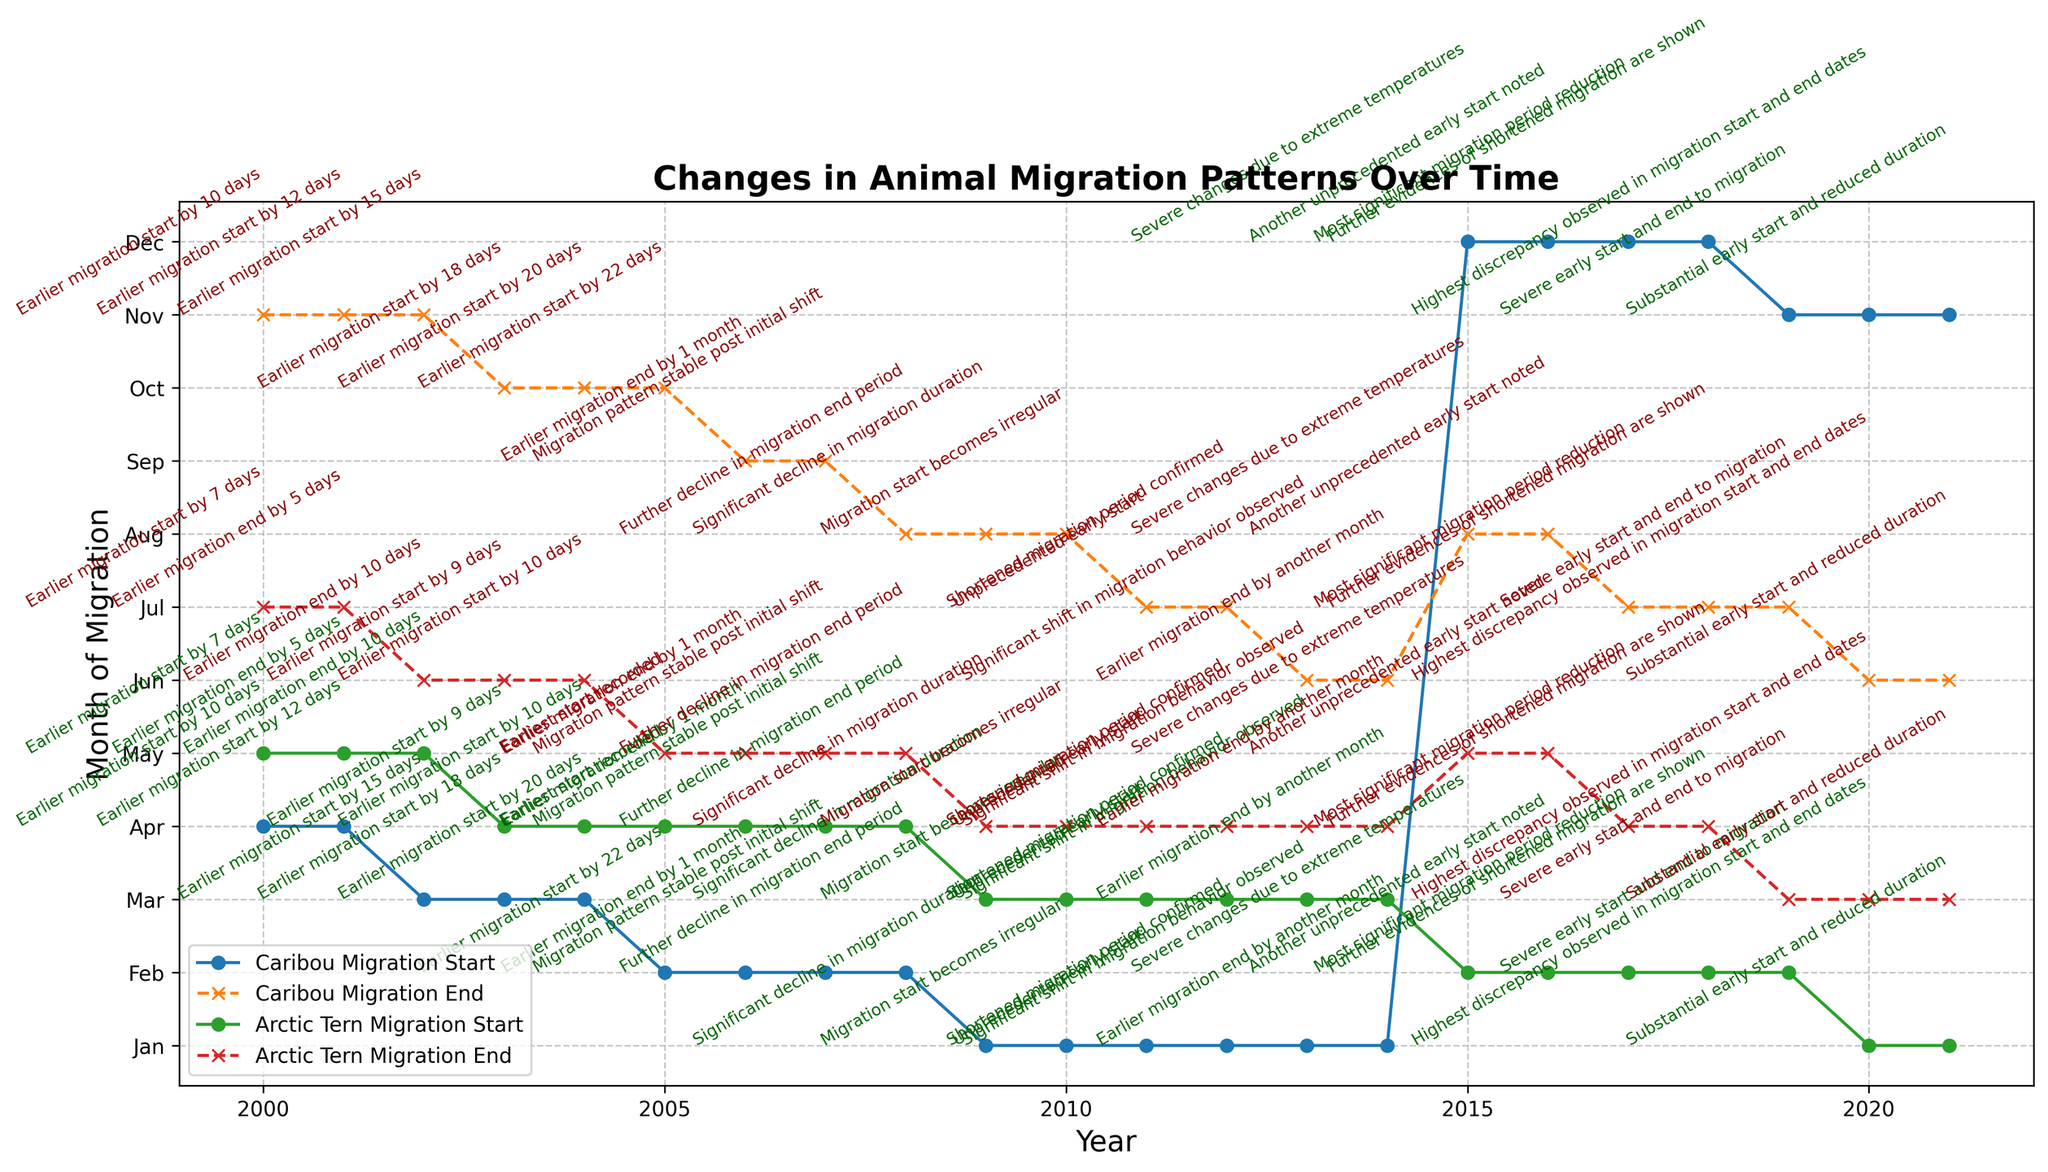Which animal had the earliest migration start in 2021? The figure indicates both the migration start and end months for each year. For 2021, check the migration start month for both Caribou and Arctic Tern. The Caribou's migration started in November, while the Arctic Tern's started in January.
Answer: Arctic Tern What was the migration end month for Caribou in 2006? Look at the end point of the line labeled "Caribou Migration End" in 2006. The figure's y-axis has month labels. In 2006, the line ends at September.
Answer: September How many years showed a significant shift in migration behavior for both animals? The text annotations indicate years with "significant shift in migration behavior observed." Look at the annotations on the figure for both Caribou and Arctic Tern. The year 2013 is noted with this significant shift for both animals.
Answer: 1 year (2013) Which animal had a migration pattern labeled "stable post initial shift" in 2007? Check the text annotations in the plot for 2007. Both Caribou and Arctic Tern lines have this label in 2007.
Answer: Both In which year did the Caribou’s migration start move to December? Follow the line labeled "Caribou Migration Start" and observe the text annotations along it until you find the shift to December. This change happens in 2015.
Answer: 2015 Which months show the greatest discrepancy in migration start and end dates for any animal? Look at the text annotations highlighting "Highest discrepancy observed in migration start and end dates." According to the annotations, this happens in 2020.
Answer: 2020 What is the latest migration end month recorded for Arctic Terns? Check the end points of the lines labeled "Arctic Tern Migration End" over all years. The latest end month is July, noted before 2006.
Answer: July How many days earlier did the Caribou start migrating in 2002? Refer to the text annotation next to the 2002 migration start point for Caribou. It mentions "Earlier migration start by 15 days."
Answer: 15 days Which months did both Caribou and Arctic Tern start migrating for the first time in 2010? Look at the migration start points for both animals in 2010 and check the text annotations. Annotations indicate "Migration start becomes irregular," pointing out specific months, January for Caribou and March for Arctic Tern.
Answer: January (Caribou) and March (Arctic Tern) Which year's data shows the "Severe changes due to extreme temperatures" for both animals? Review the text annotations for both animals looking for phrases indicating "Severe changes due to extreme temperatures." Both animals show this annotation in 2015.
Answer: 2015 